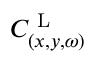<formula> <loc_0><loc_0><loc_500><loc_500>C _ { ( x , y , \omega ) } ^ { L }</formula> 